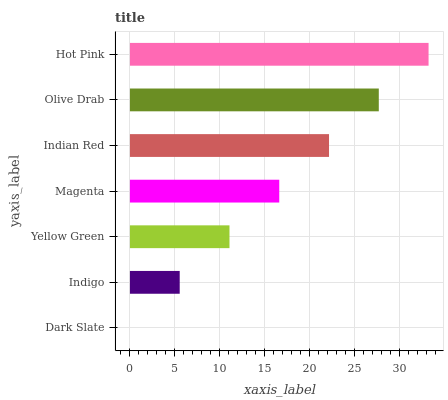Is Dark Slate the minimum?
Answer yes or no. Yes. Is Hot Pink the maximum?
Answer yes or no. Yes. Is Indigo the minimum?
Answer yes or no. No. Is Indigo the maximum?
Answer yes or no. No. Is Indigo greater than Dark Slate?
Answer yes or no. Yes. Is Dark Slate less than Indigo?
Answer yes or no. Yes. Is Dark Slate greater than Indigo?
Answer yes or no. No. Is Indigo less than Dark Slate?
Answer yes or no. No. Is Magenta the high median?
Answer yes or no. Yes. Is Magenta the low median?
Answer yes or no. Yes. Is Yellow Green the high median?
Answer yes or no. No. Is Indigo the low median?
Answer yes or no. No. 